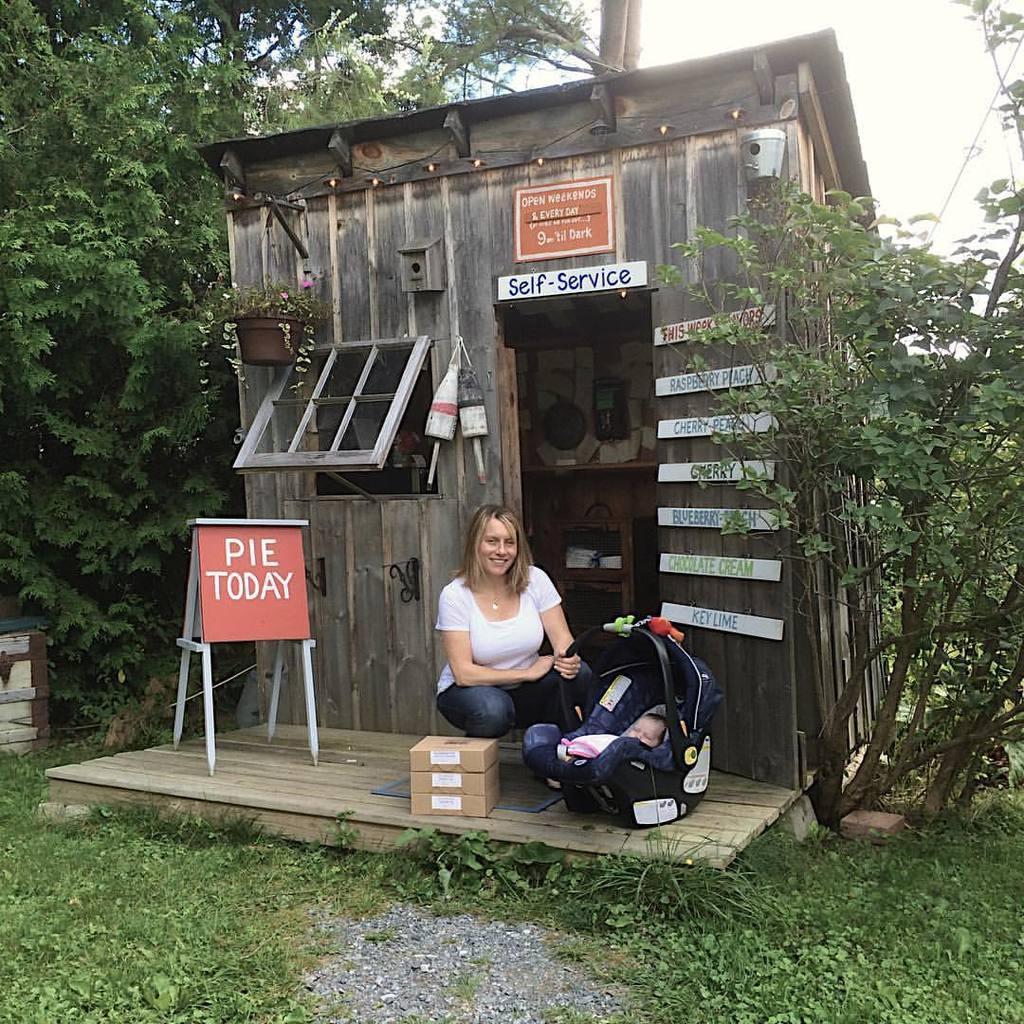In one or two sentences, can you explain what this image depicts? In this image we can see a wooden house. in front of it one woman is sitting and in one stroller one baby is there. The land is full of grass. Both side of the image trees are present. 